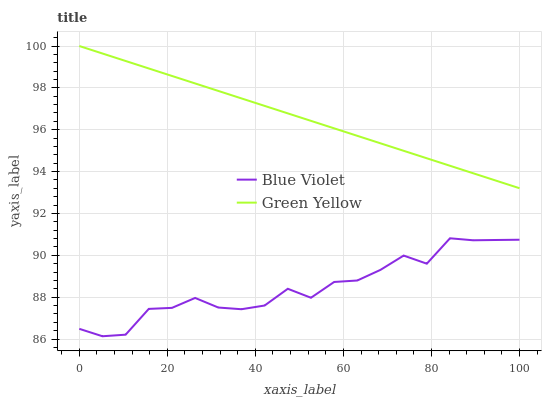Does Blue Violet have the minimum area under the curve?
Answer yes or no. Yes. Does Green Yellow have the maximum area under the curve?
Answer yes or no. Yes. Does Blue Violet have the maximum area under the curve?
Answer yes or no. No. Is Green Yellow the smoothest?
Answer yes or no. Yes. Is Blue Violet the roughest?
Answer yes or no. Yes. Is Blue Violet the smoothest?
Answer yes or no. No. Does Blue Violet have the lowest value?
Answer yes or no. Yes. Does Green Yellow have the highest value?
Answer yes or no. Yes. Does Blue Violet have the highest value?
Answer yes or no. No. Is Blue Violet less than Green Yellow?
Answer yes or no. Yes. Is Green Yellow greater than Blue Violet?
Answer yes or no. Yes. Does Blue Violet intersect Green Yellow?
Answer yes or no. No. 